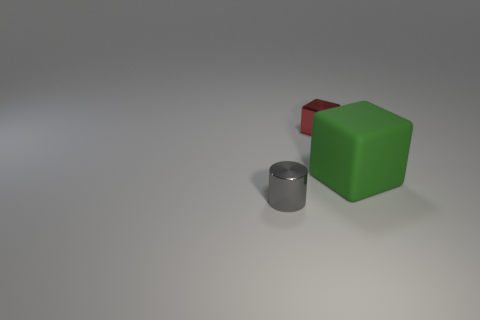Is there anything else that has the same shape as the gray metal object?
Give a very brief answer. No. How big is the thing that is both to the left of the green object and behind the small metallic cylinder?
Give a very brief answer. Small. What number of yellow things are either large things or metallic things?
Keep it short and to the point. 0. What shape is the gray shiny thing that is the same size as the metallic cube?
Offer a very short reply. Cylinder. How big is the metallic thing on the right side of the small shiny thing that is on the left side of the small block?
Provide a short and direct response. Small. Do the block on the left side of the big matte object and the green cube have the same material?
Offer a terse response. No. What shape is the small thing in front of the big green cube?
Your answer should be compact. Cylinder. What number of rubber cubes are the same size as the gray object?
Your response must be concise. 0. How big is the green cube?
Offer a very short reply. Large. What number of big objects are on the right side of the small gray metallic cylinder?
Your answer should be very brief. 1. 